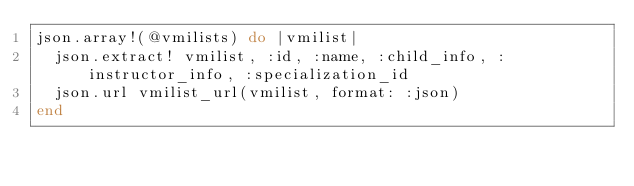Convert code to text. <code><loc_0><loc_0><loc_500><loc_500><_Ruby_>json.array!(@vmilists) do |vmilist|
  json.extract! vmilist, :id, :name, :child_info, :instructor_info, :specialization_id
  json.url vmilist_url(vmilist, format: :json)
end
</code> 